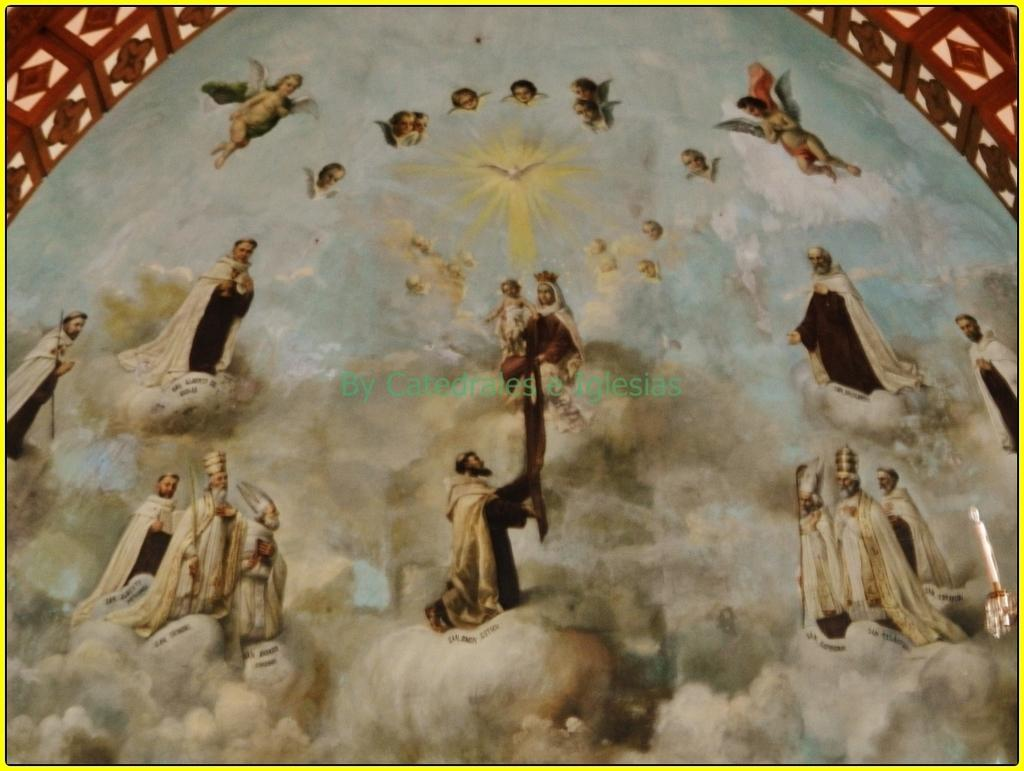What type of visual is the image? The image is a poster. What can be seen in the poster? There are persons and a bird depicted in the poster. Are there any architectural elements in the poster? Yes, there is an arch in the poster. Is there any text present in the poster? Yes, there is text in the poster. How does the poster provide comfort to the persons in the image? The poster does not provide comfort to the persons in the image, as it is a static visual and not an interactive object. 